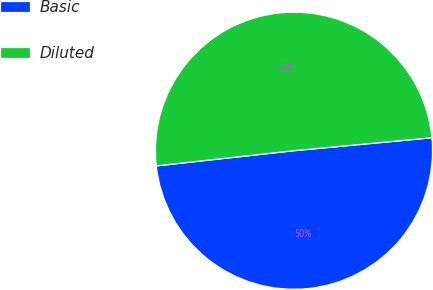<chart> <loc_0><loc_0><loc_500><loc_500><pie_chart><fcel>Basic<fcel>Diluted<nl><fcel>49.74%<fcel>50.26%<nl></chart> 